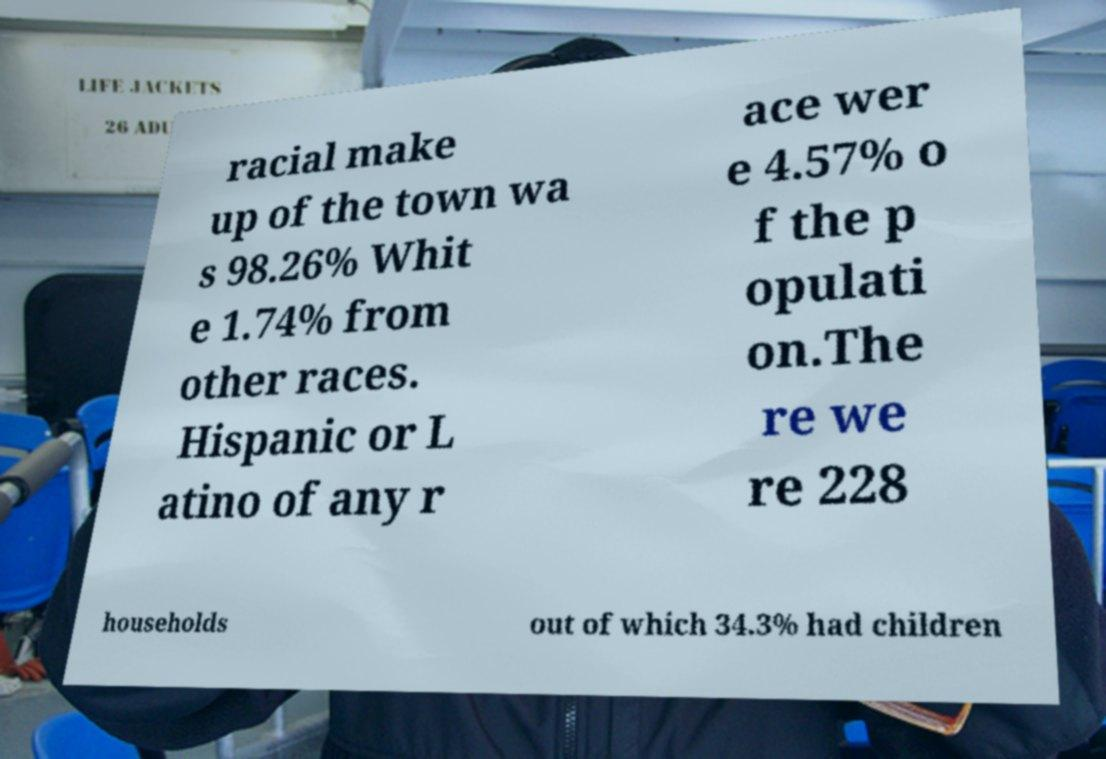There's text embedded in this image that I need extracted. Can you transcribe it verbatim? racial make up of the town wa s 98.26% Whit e 1.74% from other races. Hispanic or L atino of any r ace wer e 4.57% o f the p opulati on.The re we re 228 households out of which 34.3% had children 